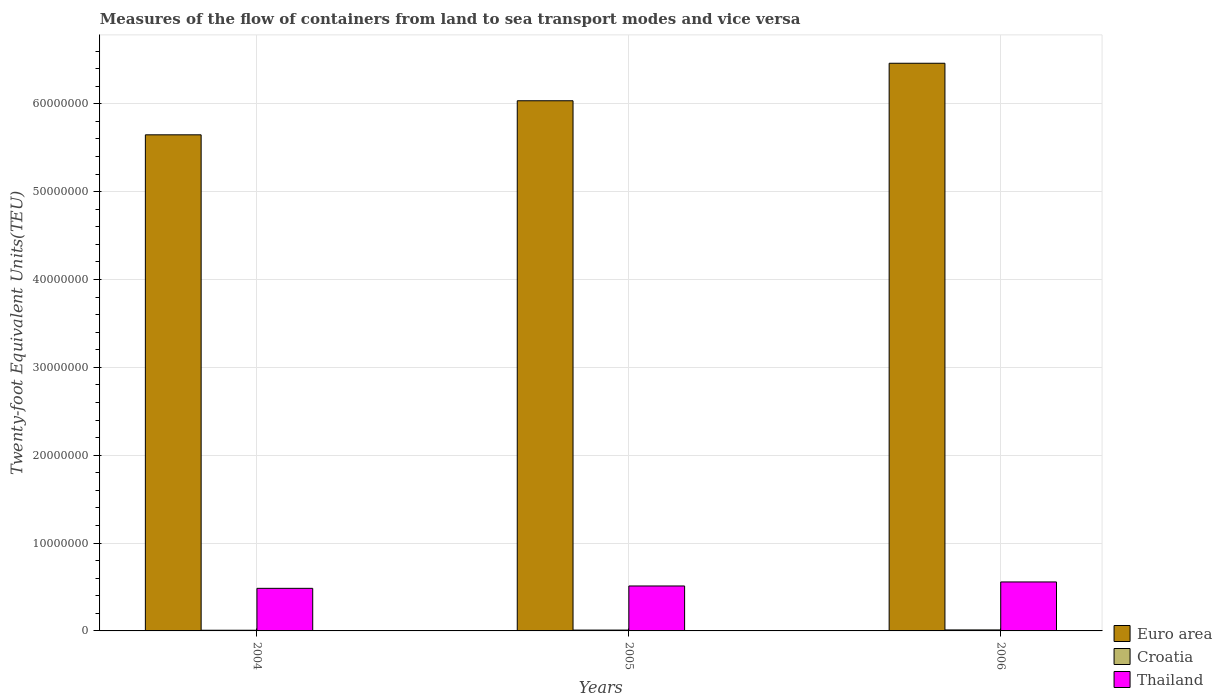How many bars are there on the 1st tick from the right?
Ensure brevity in your answer.  3. In how many cases, is the number of bars for a given year not equal to the number of legend labels?
Provide a short and direct response. 0. What is the container port traffic in Croatia in 2004?
Your response must be concise. 7.66e+04. Across all years, what is the maximum container port traffic in Croatia?
Your response must be concise. 1.13e+05. Across all years, what is the minimum container port traffic in Croatia?
Your answer should be very brief. 7.66e+04. What is the total container port traffic in Euro area in the graph?
Offer a terse response. 1.81e+08. What is the difference between the container port traffic in Euro area in 2004 and that in 2006?
Your answer should be compact. -8.15e+06. What is the difference between the container port traffic in Thailand in 2006 and the container port traffic in Euro area in 2004?
Your answer should be compact. -5.09e+07. What is the average container port traffic in Croatia per year?
Offer a very short reply. 9.46e+04. In the year 2005, what is the difference between the container port traffic in Euro area and container port traffic in Thailand?
Your answer should be very brief. 5.52e+07. What is the ratio of the container port traffic in Euro area in 2004 to that in 2005?
Your response must be concise. 0.94. Is the container port traffic in Croatia in 2004 less than that in 2006?
Provide a short and direct response. Yes. Is the difference between the container port traffic in Euro area in 2004 and 2006 greater than the difference between the container port traffic in Thailand in 2004 and 2006?
Keep it short and to the point. No. What is the difference between the highest and the second highest container port traffic in Croatia?
Make the answer very short. 1.87e+04. What is the difference between the highest and the lowest container port traffic in Croatia?
Your response must be concise. 3.64e+04. What does the 3rd bar from the left in 2006 represents?
Your answer should be compact. Thailand. What does the 3rd bar from the right in 2005 represents?
Provide a short and direct response. Euro area. Is it the case that in every year, the sum of the container port traffic in Croatia and container port traffic in Euro area is greater than the container port traffic in Thailand?
Give a very brief answer. Yes. Are all the bars in the graph horizontal?
Your response must be concise. No. What is the difference between two consecutive major ticks on the Y-axis?
Your response must be concise. 1.00e+07. Are the values on the major ticks of Y-axis written in scientific E-notation?
Your answer should be compact. No. Where does the legend appear in the graph?
Provide a short and direct response. Bottom right. How many legend labels are there?
Give a very brief answer. 3. What is the title of the graph?
Your answer should be compact. Measures of the flow of containers from land to sea transport modes and vice versa. What is the label or title of the Y-axis?
Offer a very short reply. Twenty-foot Equivalent Units(TEU). What is the Twenty-foot Equivalent Units(TEU) of Euro area in 2004?
Make the answer very short. 5.65e+07. What is the Twenty-foot Equivalent Units(TEU) in Croatia in 2004?
Provide a short and direct response. 7.66e+04. What is the Twenty-foot Equivalent Units(TEU) in Thailand in 2004?
Provide a short and direct response. 4.85e+06. What is the Twenty-foot Equivalent Units(TEU) of Euro area in 2005?
Your answer should be very brief. 6.03e+07. What is the Twenty-foot Equivalent Units(TEU) in Croatia in 2005?
Keep it short and to the point. 9.42e+04. What is the Twenty-foot Equivalent Units(TEU) in Thailand in 2005?
Keep it short and to the point. 5.12e+06. What is the Twenty-foot Equivalent Units(TEU) in Euro area in 2006?
Your response must be concise. 6.46e+07. What is the Twenty-foot Equivalent Units(TEU) in Croatia in 2006?
Make the answer very short. 1.13e+05. What is the Twenty-foot Equivalent Units(TEU) in Thailand in 2006?
Offer a very short reply. 5.57e+06. Across all years, what is the maximum Twenty-foot Equivalent Units(TEU) in Euro area?
Offer a terse response. 6.46e+07. Across all years, what is the maximum Twenty-foot Equivalent Units(TEU) of Croatia?
Offer a terse response. 1.13e+05. Across all years, what is the maximum Twenty-foot Equivalent Units(TEU) in Thailand?
Provide a succinct answer. 5.57e+06. Across all years, what is the minimum Twenty-foot Equivalent Units(TEU) of Euro area?
Offer a terse response. 5.65e+07. Across all years, what is the minimum Twenty-foot Equivalent Units(TEU) in Croatia?
Your answer should be very brief. 7.66e+04. Across all years, what is the minimum Twenty-foot Equivalent Units(TEU) of Thailand?
Keep it short and to the point. 4.85e+06. What is the total Twenty-foot Equivalent Units(TEU) in Euro area in the graph?
Provide a short and direct response. 1.81e+08. What is the total Twenty-foot Equivalent Units(TEU) of Croatia in the graph?
Make the answer very short. 2.84e+05. What is the total Twenty-foot Equivalent Units(TEU) in Thailand in the graph?
Ensure brevity in your answer.  1.55e+07. What is the difference between the Twenty-foot Equivalent Units(TEU) in Euro area in 2004 and that in 2005?
Offer a terse response. -3.88e+06. What is the difference between the Twenty-foot Equivalent Units(TEU) of Croatia in 2004 and that in 2005?
Offer a terse response. -1.77e+04. What is the difference between the Twenty-foot Equivalent Units(TEU) in Thailand in 2004 and that in 2005?
Offer a very short reply. -2.68e+05. What is the difference between the Twenty-foot Equivalent Units(TEU) of Euro area in 2004 and that in 2006?
Your response must be concise. -8.15e+06. What is the difference between the Twenty-foot Equivalent Units(TEU) of Croatia in 2004 and that in 2006?
Give a very brief answer. -3.64e+04. What is the difference between the Twenty-foot Equivalent Units(TEU) of Thailand in 2004 and that in 2006?
Your response must be concise. -7.27e+05. What is the difference between the Twenty-foot Equivalent Units(TEU) of Euro area in 2005 and that in 2006?
Your response must be concise. -4.27e+06. What is the difference between the Twenty-foot Equivalent Units(TEU) in Croatia in 2005 and that in 2006?
Offer a terse response. -1.87e+04. What is the difference between the Twenty-foot Equivalent Units(TEU) of Thailand in 2005 and that in 2006?
Ensure brevity in your answer.  -4.59e+05. What is the difference between the Twenty-foot Equivalent Units(TEU) in Euro area in 2004 and the Twenty-foot Equivalent Units(TEU) in Croatia in 2005?
Provide a succinct answer. 5.64e+07. What is the difference between the Twenty-foot Equivalent Units(TEU) in Euro area in 2004 and the Twenty-foot Equivalent Units(TEU) in Thailand in 2005?
Give a very brief answer. 5.13e+07. What is the difference between the Twenty-foot Equivalent Units(TEU) of Croatia in 2004 and the Twenty-foot Equivalent Units(TEU) of Thailand in 2005?
Make the answer very short. -5.04e+06. What is the difference between the Twenty-foot Equivalent Units(TEU) of Euro area in 2004 and the Twenty-foot Equivalent Units(TEU) of Croatia in 2006?
Provide a succinct answer. 5.64e+07. What is the difference between the Twenty-foot Equivalent Units(TEU) of Euro area in 2004 and the Twenty-foot Equivalent Units(TEU) of Thailand in 2006?
Provide a short and direct response. 5.09e+07. What is the difference between the Twenty-foot Equivalent Units(TEU) of Croatia in 2004 and the Twenty-foot Equivalent Units(TEU) of Thailand in 2006?
Provide a succinct answer. -5.50e+06. What is the difference between the Twenty-foot Equivalent Units(TEU) in Euro area in 2005 and the Twenty-foot Equivalent Units(TEU) in Croatia in 2006?
Your response must be concise. 6.02e+07. What is the difference between the Twenty-foot Equivalent Units(TEU) in Euro area in 2005 and the Twenty-foot Equivalent Units(TEU) in Thailand in 2006?
Your response must be concise. 5.48e+07. What is the difference between the Twenty-foot Equivalent Units(TEU) in Croatia in 2005 and the Twenty-foot Equivalent Units(TEU) in Thailand in 2006?
Make the answer very short. -5.48e+06. What is the average Twenty-foot Equivalent Units(TEU) in Euro area per year?
Ensure brevity in your answer.  6.05e+07. What is the average Twenty-foot Equivalent Units(TEU) of Croatia per year?
Ensure brevity in your answer.  9.46e+04. What is the average Twenty-foot Equivalent Units(TEU) of Thailand per year?
Keep it short and to the point. 5.18e+06. In the year 2004, what is the difference between the Twenty-foot Equivalent Units(TEU) in Euro area and Twenty-foot Equivalent Units(TEU) in Croatia?
Your response must be concise. 5.64e+07. In the year 2004, what is the difference between the Twenty-foot Equivalent Units(TEU) of Euro area and Twenty-foot Equivalent Units(TEU) of Thailand?
Your answer should be very brief. 5.16e+07. In the year 2004, what is the difference between the Twenty-foot Equivalent Units(TEU) in Croatia and Twenty-foot Equivalent Units(TEU) in Thailand?
Provide a succinct answer. -4.77e+06. In the year 2005, what is the difference between the Twenty-foot Equivalent Units(TEU) in Euro area and Twenty-foot Equivalent Units(TEU) in Croatia?
Your answer should be compact. 6.02e+07. In the year 2005, what is the difference between the Twenty-foot Equivalent Units(TEU) in Euro area and Twenty-foot Equivalent Units(TEU) in Thailand?
Offer a very short reply. 5.52e+07. In the year 2005, what is the difference between the Twenty-foot Equivalent Units(TEU) in Croatia and Twenty-foot Equivalent Units(TEU) in Thailand?
Your response must be concise. -5.02e+06. In the year 2006, what is the difference between the Twenty-foot Equivalent Units(TEU) of Euro area and Twenty-foot Equivalent Units(TEU) of Croatia?
Offer a very short reply. 6.45e+07. In the year 2006, what is the difference between the Twenty-foot Equivalent Units(TEU) in Euro area and Twenty-foot Equivalent Units(TEU) in Thailand?
Provide a succinct answer. 5.90e+07. In the year 2006, what is the difference between the Twenty-foot Equivalent Units(TEU) of Croatia and Twenty-foot Equivalent Units(TEU) of Thailand?
Offer a terse response. -5.46e+06. What is the ratio of the Twenty-foot Equivalent Units(TEU) of Euro area in 2004 to that in 2005?
Make the answer very short. 0.94. What is the ratio of the Twenty-foot Equivalent Units(TEU) of Croatia in 2004 to that in 2005?
Give a very brief answer. 0.81. What is the ratio of the Twenty-foot Equivalent Units(TEU) in Thailand in 2004 to that in 2005?
Your answer should be very brief. 0.95. What is the ratio of the Twenty-foot Equivalent Units(TEU) in Euro area in 2004 to that in 2006?
Your answer should be compact. 0.87. What is the ratio of the Twenty-foot Equivalent Units(TEU) of Croatia in 2004 to that in 2006?
Offer a very short reply. 0.68. What is the ratio of the Twenty-foot Equivalent Units(TEU) of Thailand in 2004 to that in 2006?
Give a very brief answer. 0.87. What is the ratio of the Twenty-foot Equivalent Units(TEU) in Euro area in 2005 to that in 2006?
Keep it short and to the point. 0.93. What is the ratio of the Twenty-foot Equivalent Units(TEU) in Croatia in 2005 to that in 2006?
Give a very brief answer. 0.83. What is the ratio of the Twenty-foot Equivalent Units(TEU) in Thailand in 2005 to that in 2006?
Provide a succinct answer. 0.92. What is the difference between the highest and the second highest Twenty-foot Equivalent Units(TEU) in Euro area?
Give a very brief answer. 4.27e+06. What is the difference between the highest and the second highest Twenty-foot Equivalent Units(TEU) of Croatia?
Keep it short and to the point. 1.87e+04. What is the difference between the highest and the second highest Twenty-foot Equivalent Units(TEU) in Thailand?
Give a very brief answer. 4.59e+05. What is the difference between the highest and the lowest Twenty-foot Equivalent Units(TEU) in Euro area?
Your answer should be very brief. 8.15e+06. What is the difference between the highest and the lowest Twenty-foot Equivalent Units(TEU) in Croatia?
Make the answer very short. 3.64e+04. What is the difference between the highest and the lowest Twenty-foot Equivalent Units(TEU) in Thailand?
Your response must be concise. 7.27e+05. 